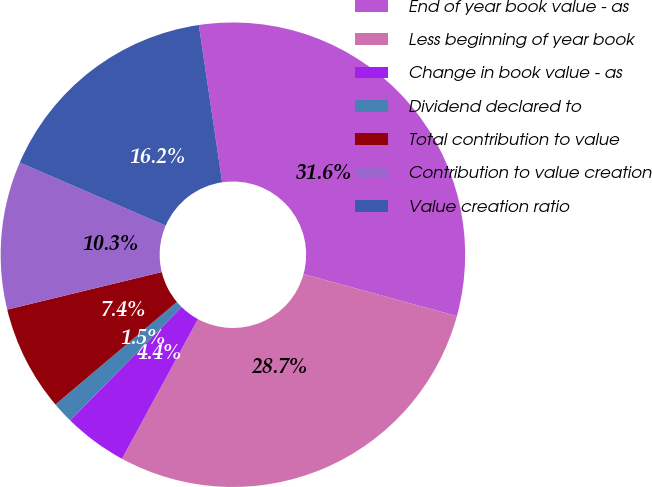<chart> <loc_0><loc_0><loc_500><loc_500><pie_chart><fcel>End of year book value - as<fcel>Less beginning of year book<fcel>Change in book value - as<fcel>Dividend declared to<fcel>Total contribution to value<fcel>Contribution to value creation<fcel>Value creation ratio<nl><fcel>31.6%<fcel>28.67%<fcel>4.43%<fcel>1.49%<fcel>7.36%<fcel>10.29%<fcel>16.16%<nl></chart> 